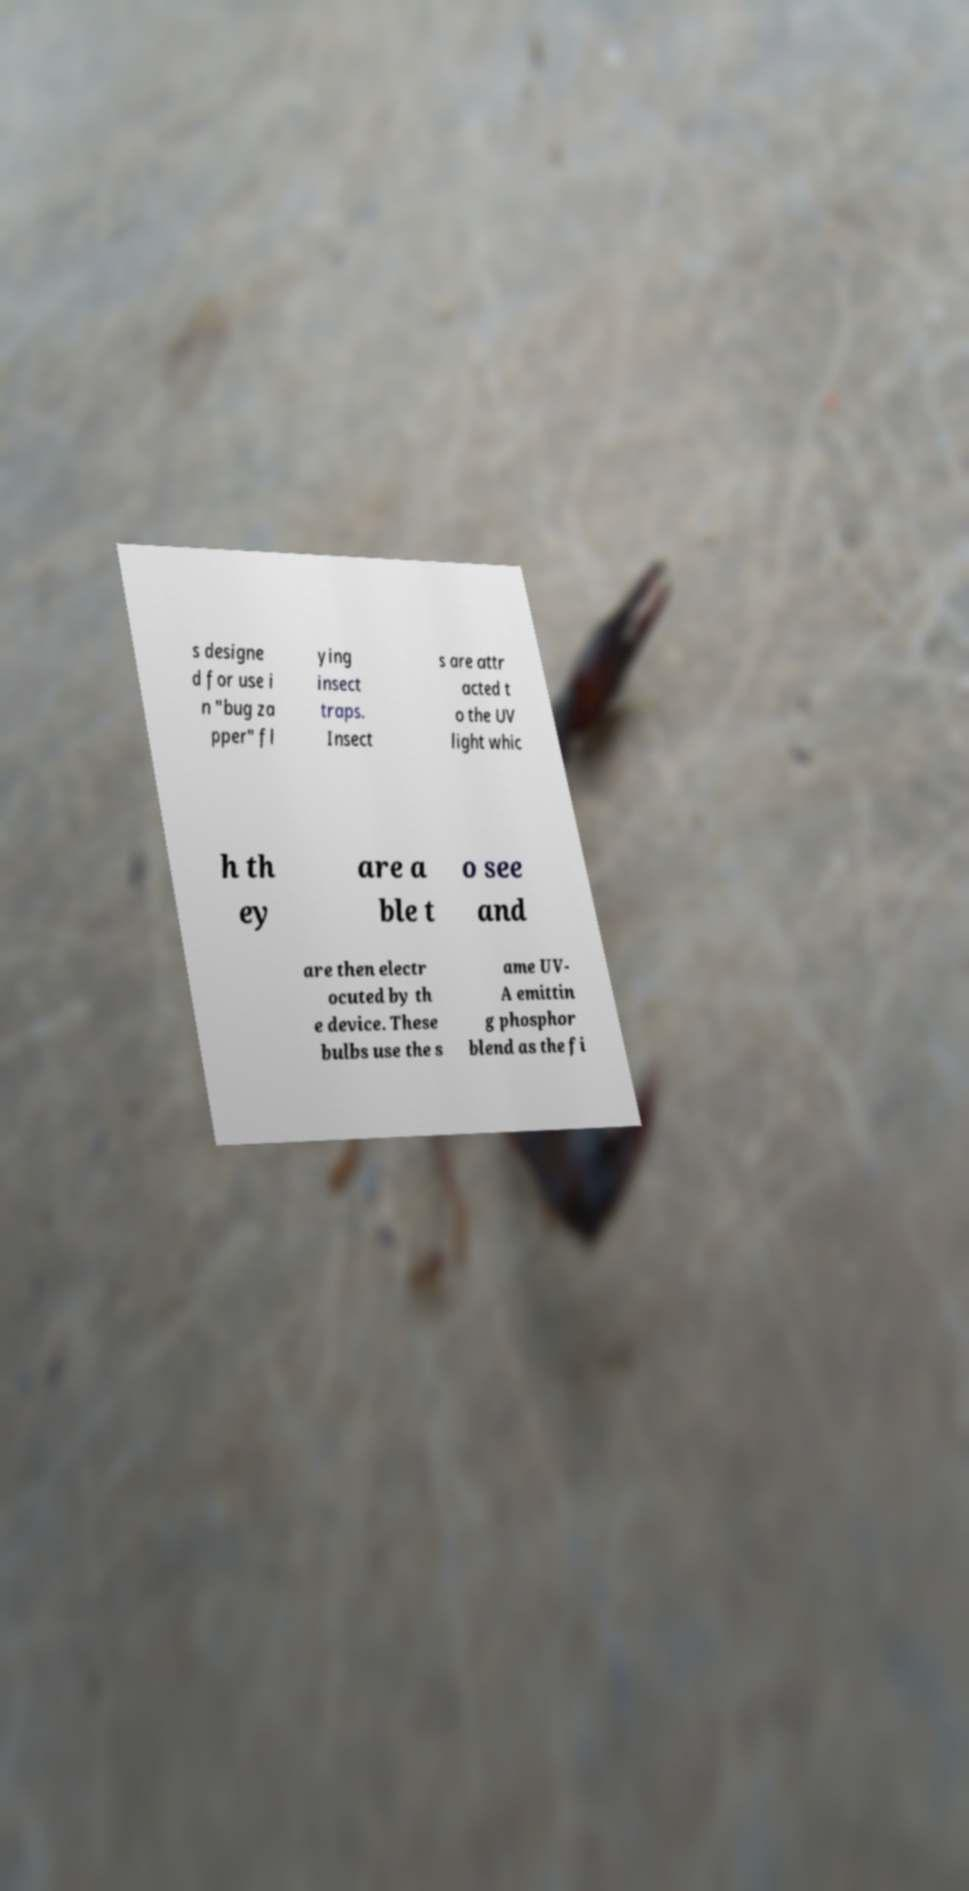Could you assist in decoding the text presented in this image and type it out clearly? s designe d for use i n "bug za pper" fl ying insect traps. Insect s are attr acted t o the UV light whic h th ey are a ble t o see and are then electr ocuted by th e device. These bulbs use the s ame UV- A emittin g phosphor blend as the fi 